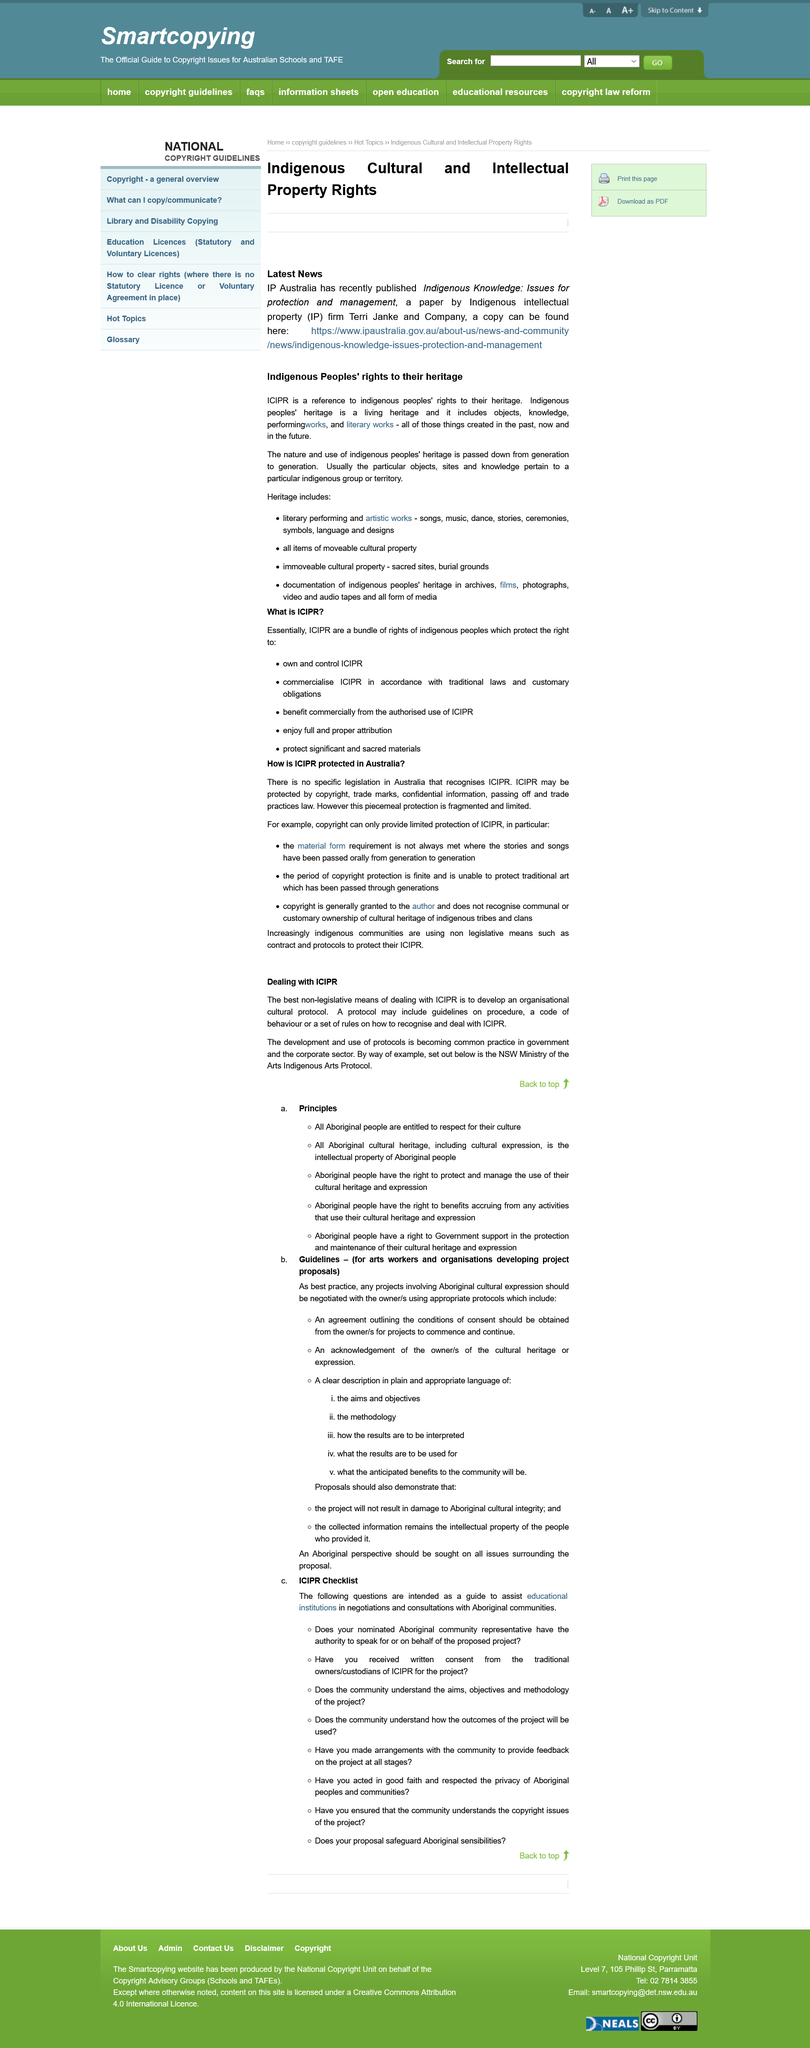Specify some key components in this picture. The title of the paper published by IP Australia is "Indigenous Knowledge: Issues for protection and management." It is best practice for projects involving Aboriginal cultural expression to negotiate with the owner/s using appropriate protocols in order to ensure respectful and culturally sensitive outcomes. The heritage of the indigenous people is created in the past, present, and future and includes all classified items. It is imperative that all Aboriginal people are afforded the utmost respect for their culture, as they are entitled to such treatment. The page is seeking to answer the question of how ICIPR is protected in Australia. 